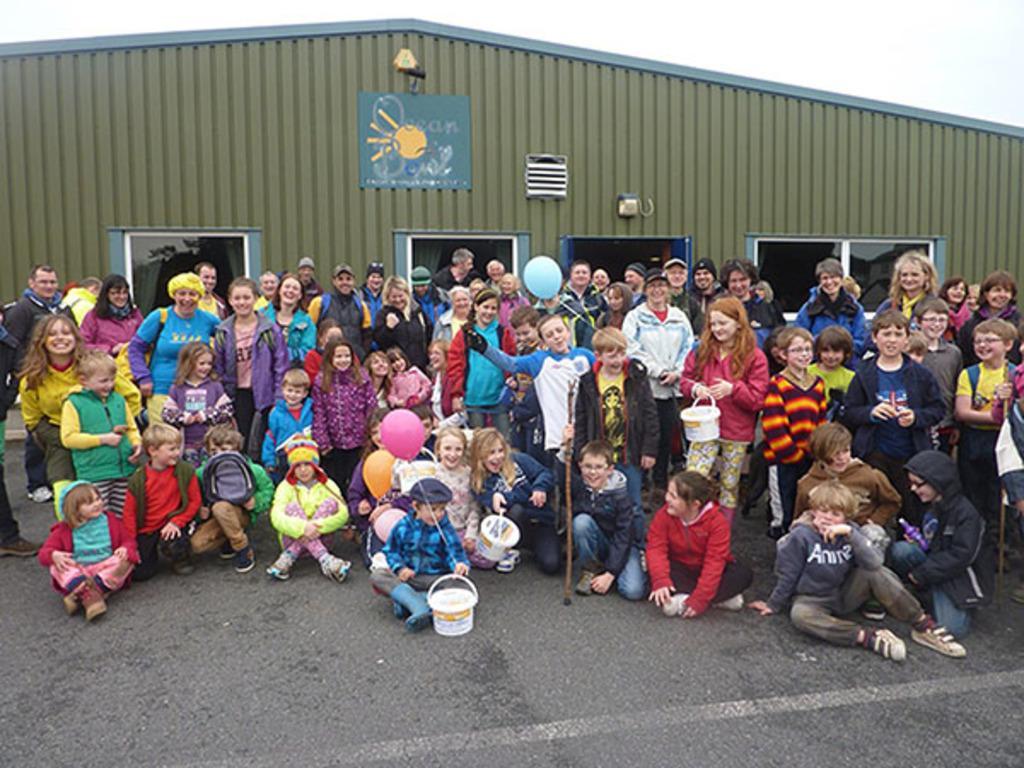Can you describe this image briefly? In this picture we can see some people standing here, there are some people sitting here, we can see a room in the background, there is a balloon here, we can see a bucket here, there is the sky at the top of the picture, we can see a window here. 